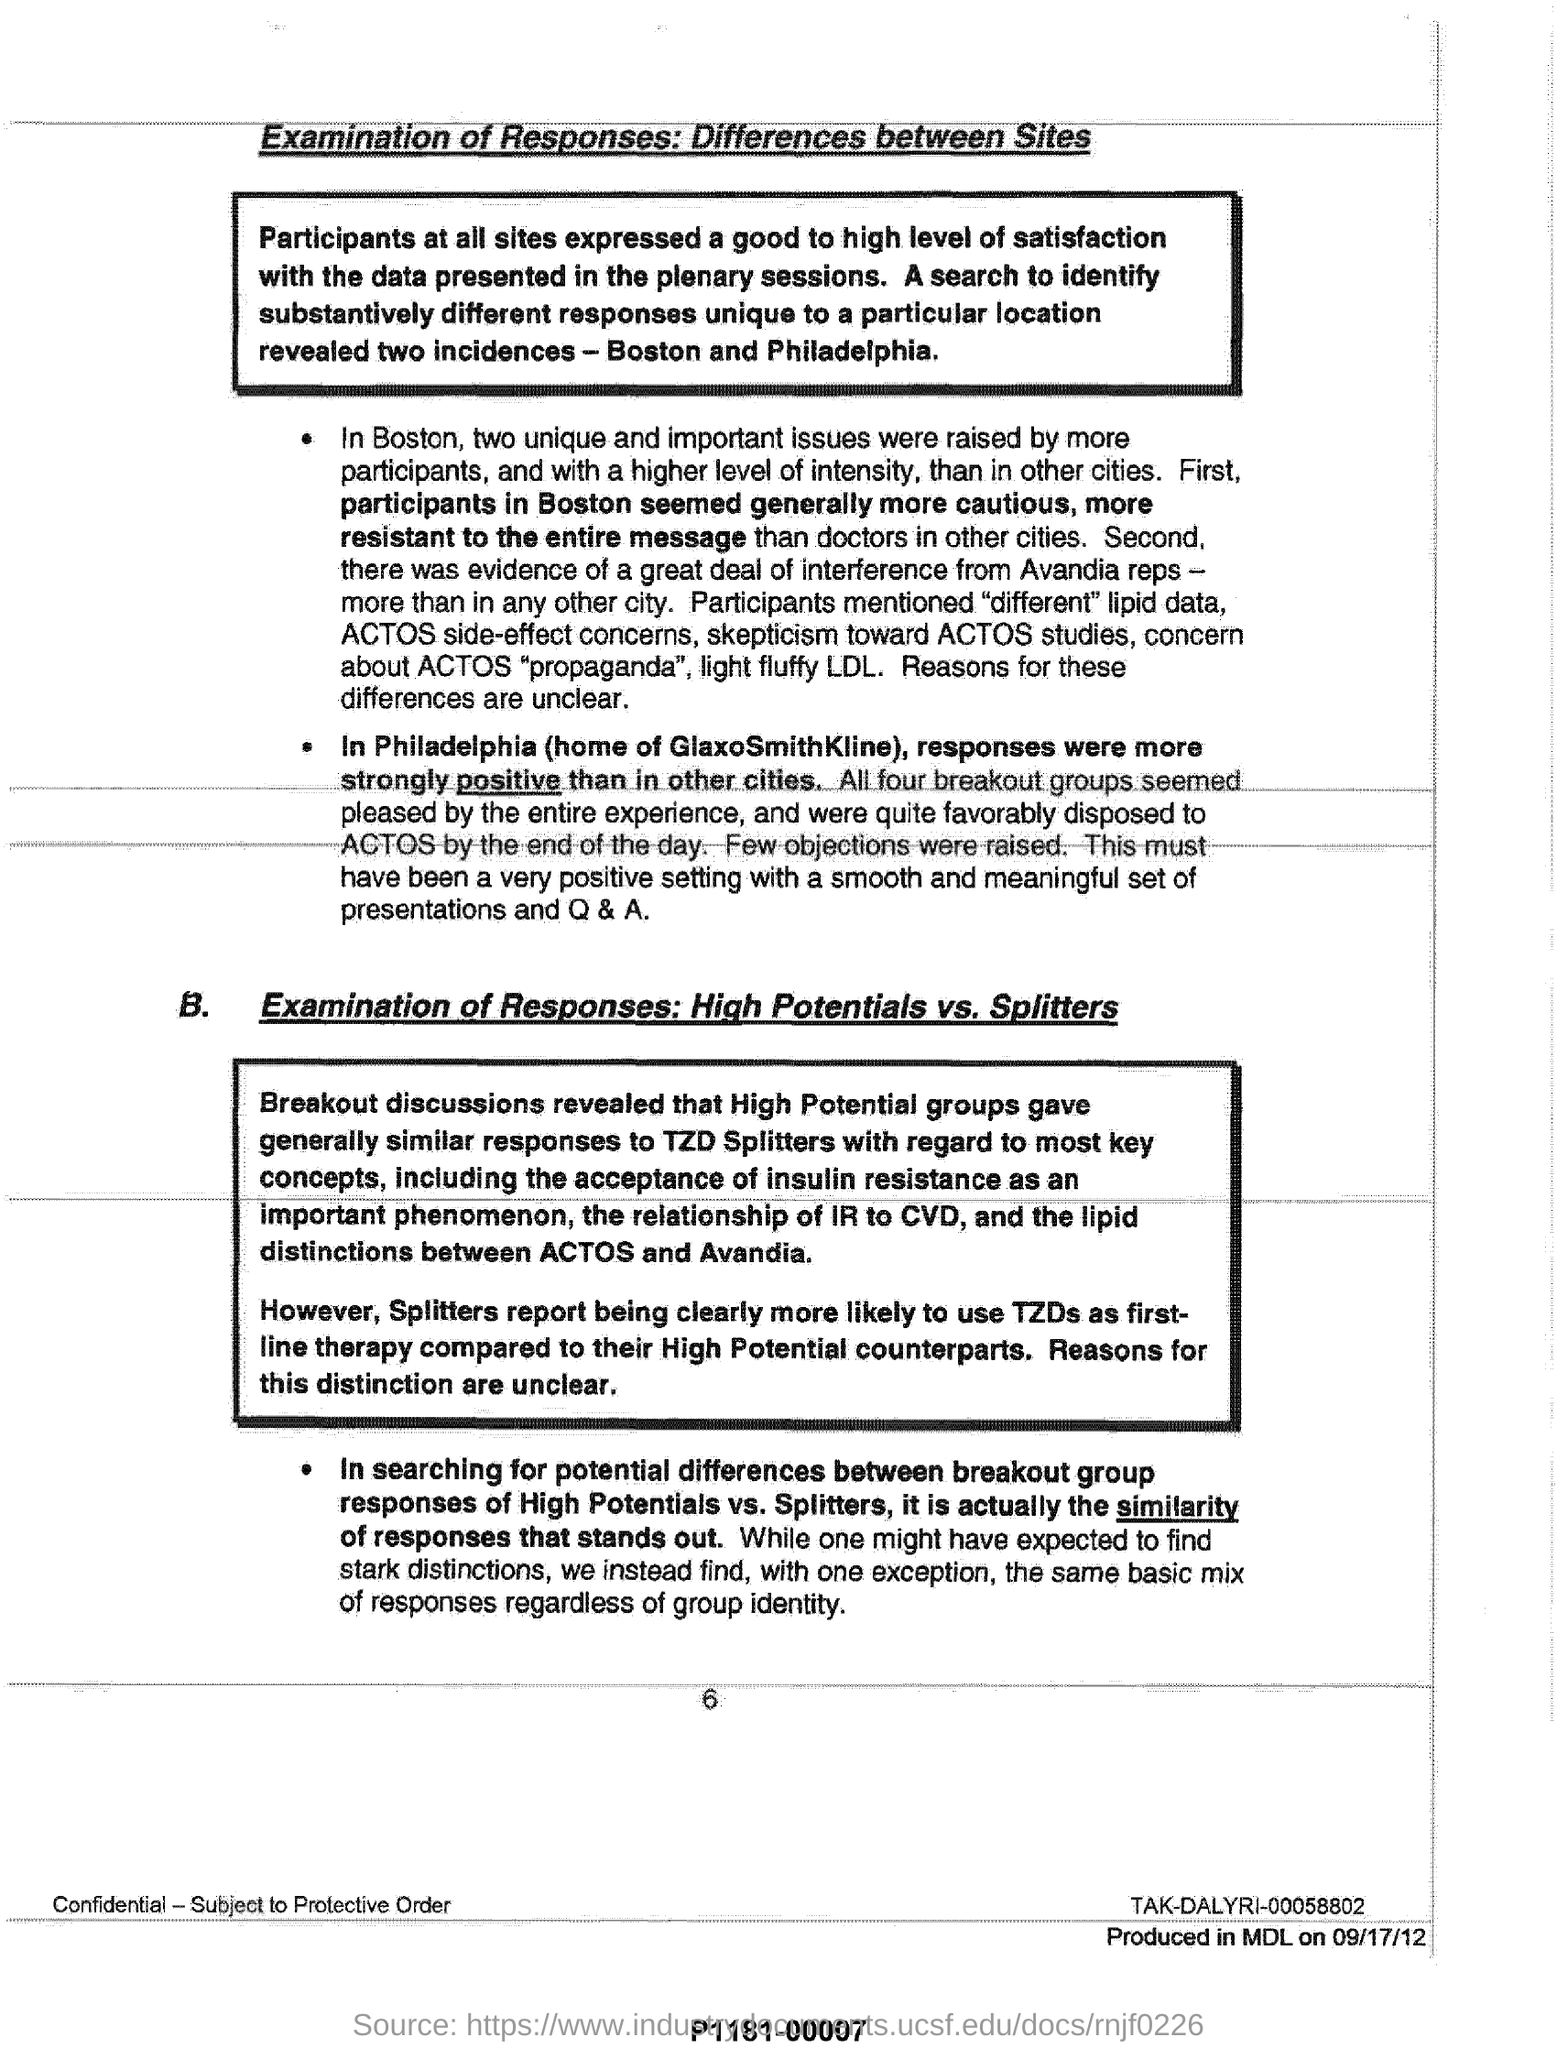Highlight a few significant elements in this photo. The responses were more favorable in Philadelphia than in other cities. The participants in Boston appeared to be more cautious and resistant to the entire message than those in the other cities. 